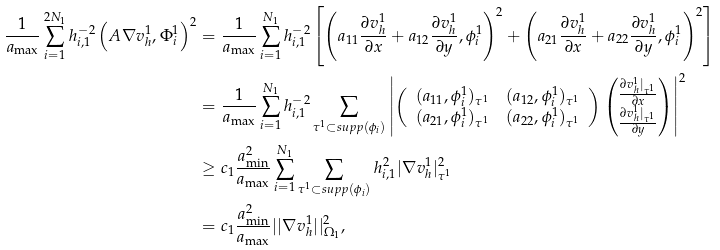<formula> <loc_0><loc_0><loc_500><loc_500>\frac { 1 } { a _ { \max } } \sum _ { i = 1 } ^ { 2 N _ { 1 } } h _ { i , 1 } ^ { - 2 } \left ( A \nabla v ^ { 1 } _ { h } , \Phi ^ { 1 } _ { i } \right ) ^ { 2 } & = \frac { 1 } { a _ { \max } } \sum _ { i = 1 } ^ { N _ { 1 } } h _ { i , 1 } ^ { - 2 } \left [ \left ( a _ { 1 1 } \frac { \partial v ^ { 1 } _ { h } } { \partial x } + a _ { 1 2 } \frac { \partial v ^ { 1 } _ { h } } { \partial y } , \phi ^ { 1 } _ { i } \right ) ^ { 2 } + \left ( a _ { 2 1 } \frac { \partial v ^ { 1 } _ { h } } { \partial x } + a _ { 2 2 } \frac { \partial v ^ { 1 } _ { h } } { \partial y } , \phi ^ { 1 } _ { i } \right ) ^ { 2 } \right ] \\ & = \frac { 1 } { a _ { \max } } \sum _ { i = 1 } ^ { N _ { 1 } } h _ { i , 1 } ^ { - 2 } \sum _ { \tau ^ { 1 } \subset s u p p ( \phi _ { i } ) } \left | \left ( \begin{array} { c c } ( a _ { 1 1 } , \phi ^ { 1 } _ { i } ) _ { \tau ^ { 1 } } & ( a _ { 1 2 } , \phi ^ { 1 } _ { i } ) _ { \tau ^ { 1 } } \\ ( a _ { 2 1 } , \phi ^ { 1 } _ { i } ) _ { \tau ^ { 1 } } & ( a _ { 2 2 } , \phi ^ { 1 } _ { i } ) _ { \tau ^ { 1 } } \end{array} \right ) \begin{pmatrix} \frac { \partial v ^ { 1 } _ { h } | _ { \tau ^ { 1 } } } { \partial x } \\ \frac { \partial v ^ { 1 } _ { h } | _ { \tau ^ { 1 } } } { \partial y } \end{pmatrix} \right | ^ { 2 } \\ & \geq c _ { 1 } \frac { a ^ { 2 } _ { \min } } { a _ { \max } } \sum _ { i = 1 } ^ { N _ { 1 } } \sum _ { \tau ^ { 1 } \subset s u p p ( \phi _ { i } ) } h _ { i , 1 } ^ { 2 } | \nabla v ^ { 1 } _ { h } | ^ { 2 } _ { \tau ^ { 1 } } \\ & = c _ { 1 } \frac { a ^ { 2 } _ { \min } } { a _ { \max } } | | \nabla v ^ { 1 } _ { h } | | ^ { 2 } _ { \Omega _ { 1 } } ,</formula> 